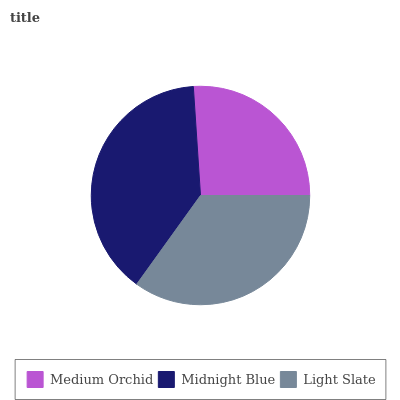Is Medium Orchid the minimum?
Answer yes or no. Yes. Is Midnight Blue the maximum?
Answer yes or no. Yes. Is Light Slate the minimum?
Answer yes or no. No. Is Light Slate the maximum?
Answer yes or no. No. Is Midnight Blue greater than Light Slate?
Answer yes or no. Yes. Is Light Slate less than Midnight Blue?
Answer yes or no. Yes. Is Light Slate greater than Midnight Blue?
Answer yes or no. No. Is Midnight Blue less than Light Slate?
Answer yes or no. No. Is Light Slate the high median?
Answer yes or no. Yes. Is Light Slate the low median?
Answer yes or no. Yes. Is Medium Orchid the high median?
Answer yes or no. No. Is Medium Orchid the low median?
Answer yes or no. No. 